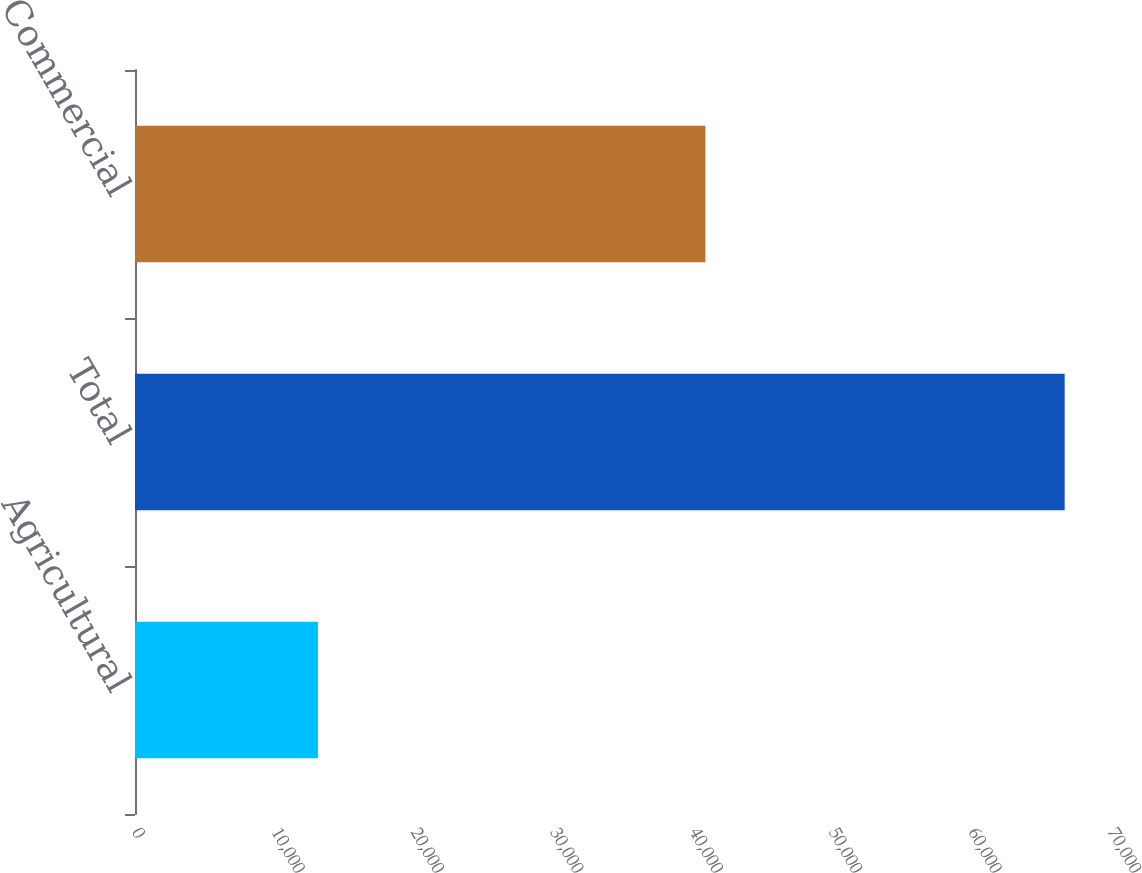Convert chart to OTSL. <chart><loc_0><loc_0><loc_500><loc_500><bar_chart><fcel>Agricultural<fcel>Total<fcel>Commercial<nl><fcel>13120<fcel>66678<fcel>40913<nl></chart> 